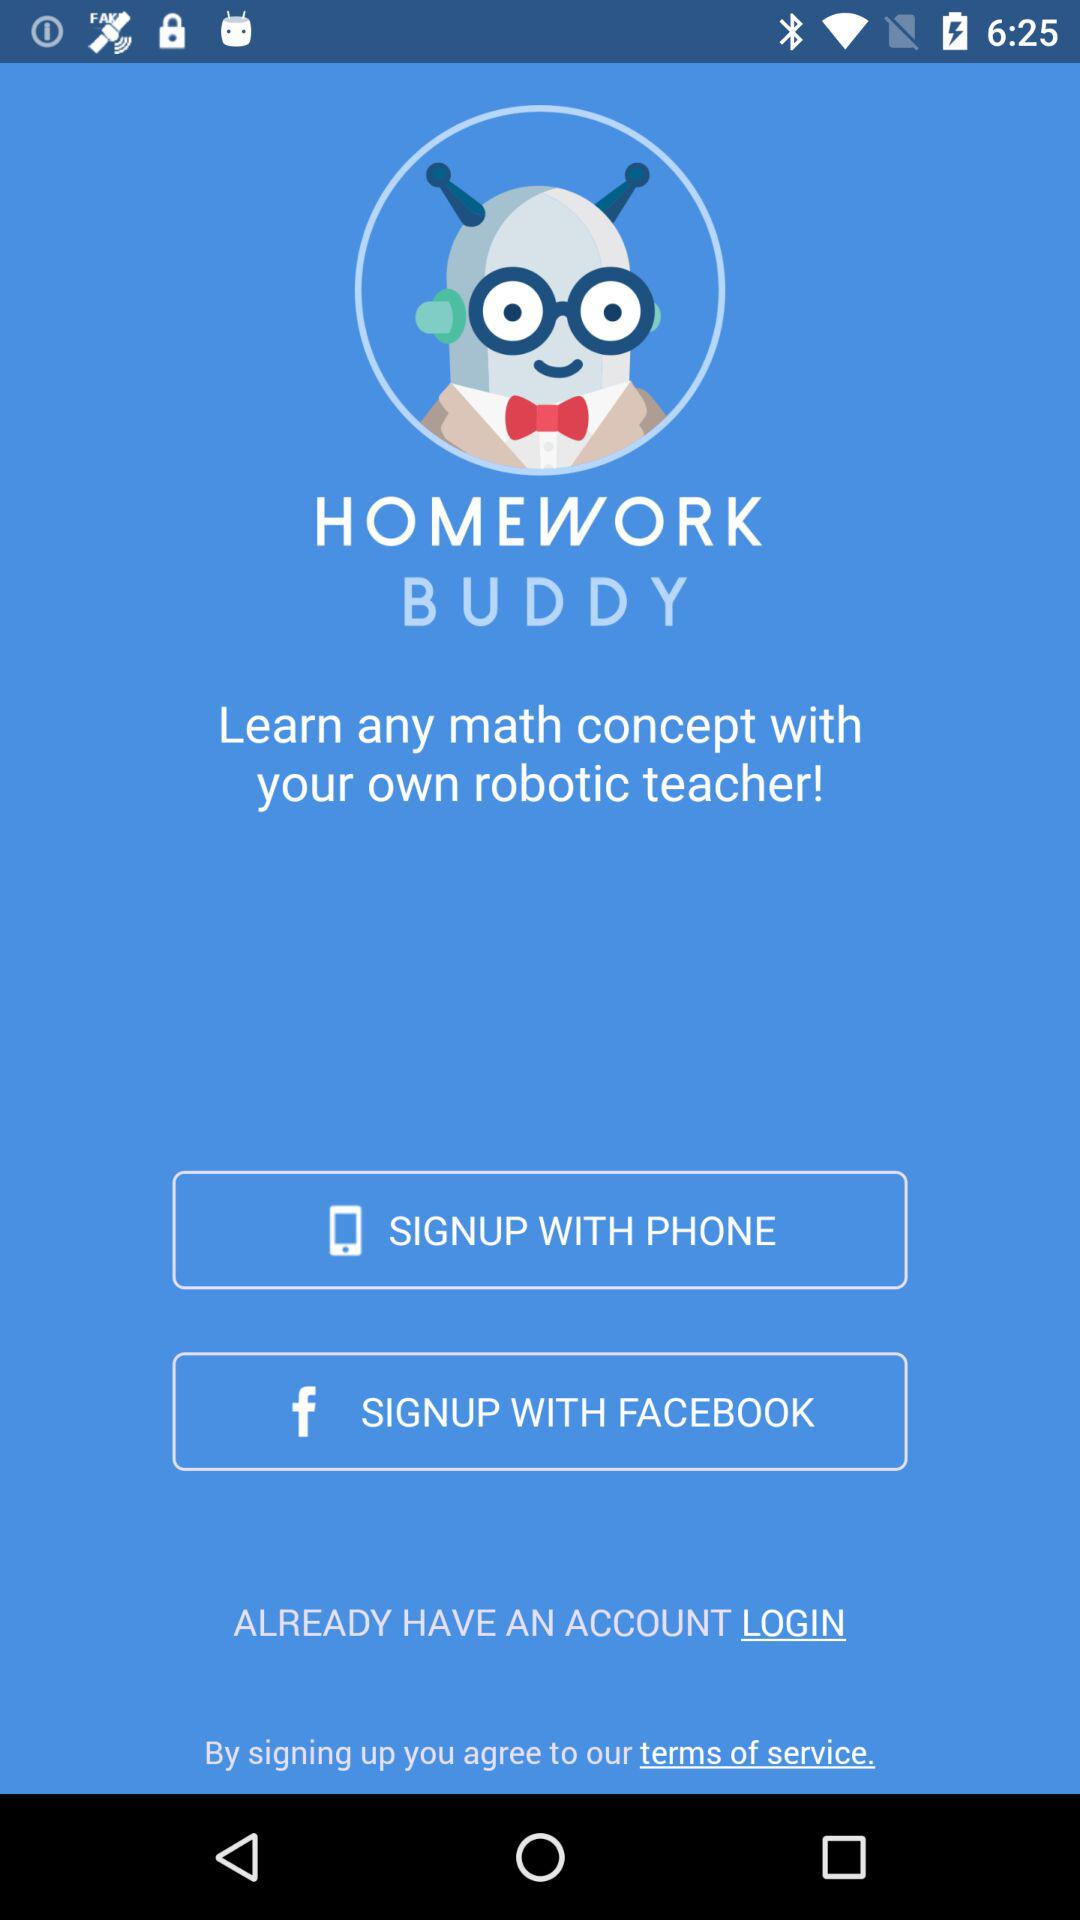Through what application can we sign up? You can sign up through "FACEBOOK". 